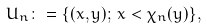<formula> <loc_0><loc_0><loc_500><loc_500>U _ { n } \colon = \{ ( x , y ) ; \, x < \chi _ { n } ( y ) \} ,</formula> 